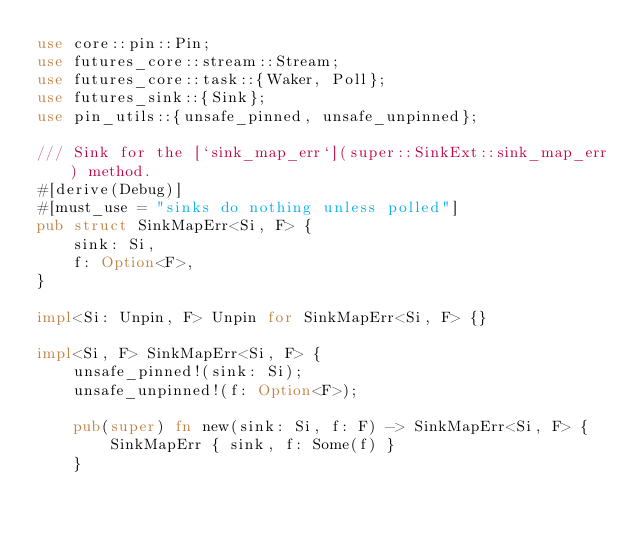Convert code to text. <code><loc_0><loc_0><loc_500><loc_500><_Rust_>use core::pin::Pin;
use futures_core::stream::Stream;
use futures_core::task::{Waker, Poll};
use futures_sink::{Sink};
use pin_utils::{unsafe_pinned, unsafe_unpinned};

/// Sink for the [`sink_map_err`](super::SinkExt::sink_map_err) method.
#[derive(Debug)]
#[must_use = "sinks do nothing unless polled"]
pub struct SinkMapErr<Si, F> {
    sink: Si,
    f: Option<F>,
}

impl<Si: Unpin, F> Unpin for SinkMapErr<Si, F> {}

impl<Si, F> SinkMapErr<Si, F> {
    unsafe_pinned!(sink: Si);
    unsafe_unpinned!(f: Option<F>);

    pub(super) fn new(sink: Si, f: F) -> SinkMapErr<Si, F> {
        SinkMapErr { sink, f: Some(f) }
    }
</code> 